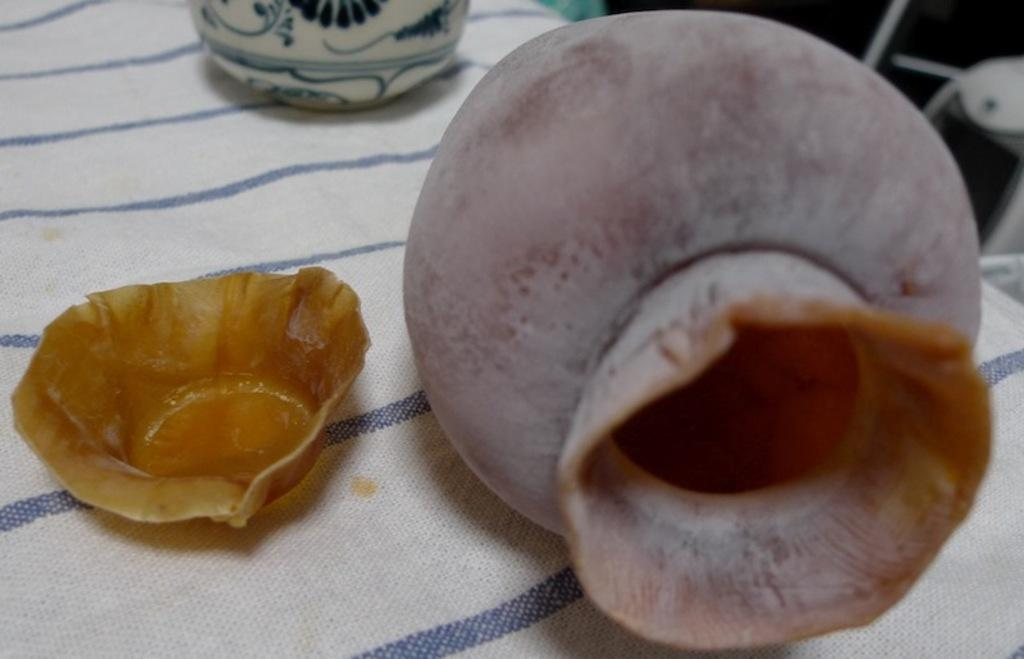What object is located on the right side of the image? There is a pot on the right side of the image. What object is located on the left side of the image? There is a paper cup on the left side of the image. What is the surface on which both the pot and paper cup are placed? Both the pot and paper cup are on a cloth. What can be seen in the background of the image? There is a jar visible in the background of the image. What type of glue is being used by the beast in the committee in the image? There is no beast, committee, or glue present in the image. 